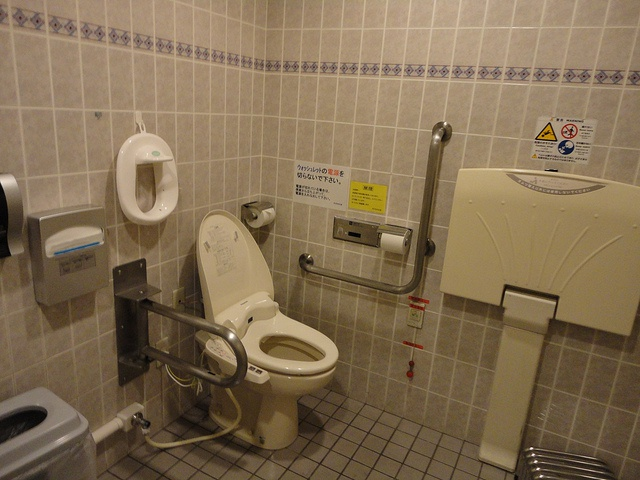Describe the objects in this image and their specific colors. I can see a toilet in gray, tan, olive, and black tones in this image. 